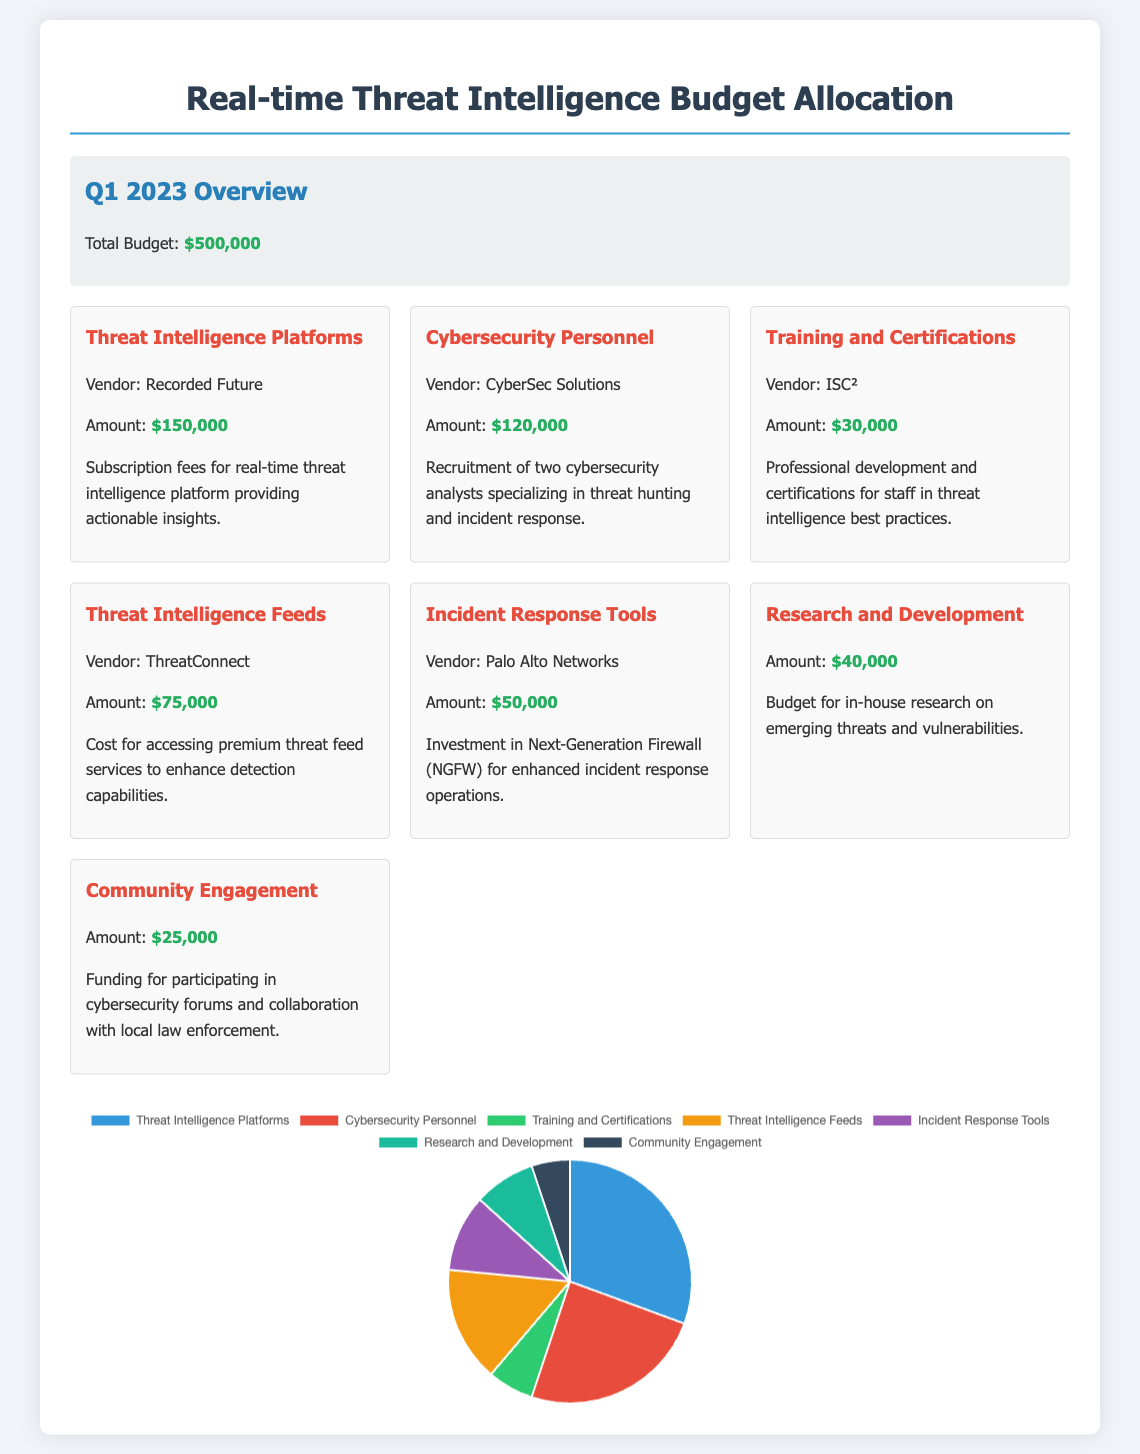what is the total budget? The total budget is stated in the budget summary section of the document.
Answer: $500,000 how much is allocated for Threat Intelligence Platforms? The amount allocated for Threat Intelligence Platforms is detailed under the respective expenditure item.
Answer: $150,000 who is the vendor for Cybersecurity Personnel? The vendor for Cybersecurity Personnel is listed under the corresponding expenditure item.
Answer: CyberSec Solutions what is the amount spent on Training and Certifications? The expenditure for Training and Certifications is specified in the document.
Answer: $30,000 which tool costs $50,000? The tool costing $50,000 is mentioned specifically in the document.
Answer: Incident Response Tools what percentage of the total budget is allocated for Community Engagement? This requires calculating the percentage of Community Engagement in relation to the total budget.
Answer: 5% how many cybersecurity analysts are being recruited? The document states the number of analysts being recruited in the description of that expenditure item.
Answer: Two what type of chart is used in the document? The type of chart is specified within the chart section for visual representation.
Answer: Pie what is the purpose of the Research and Development expenditure? The purpose is clarified within the spending item description.
Answer: Emerging threats and vulnerabilities which vendor is associated with the Threat Intelligence Feeds? The associated vendor is mentioned in the respective expenditure item.
Answer: ThreatConnect 